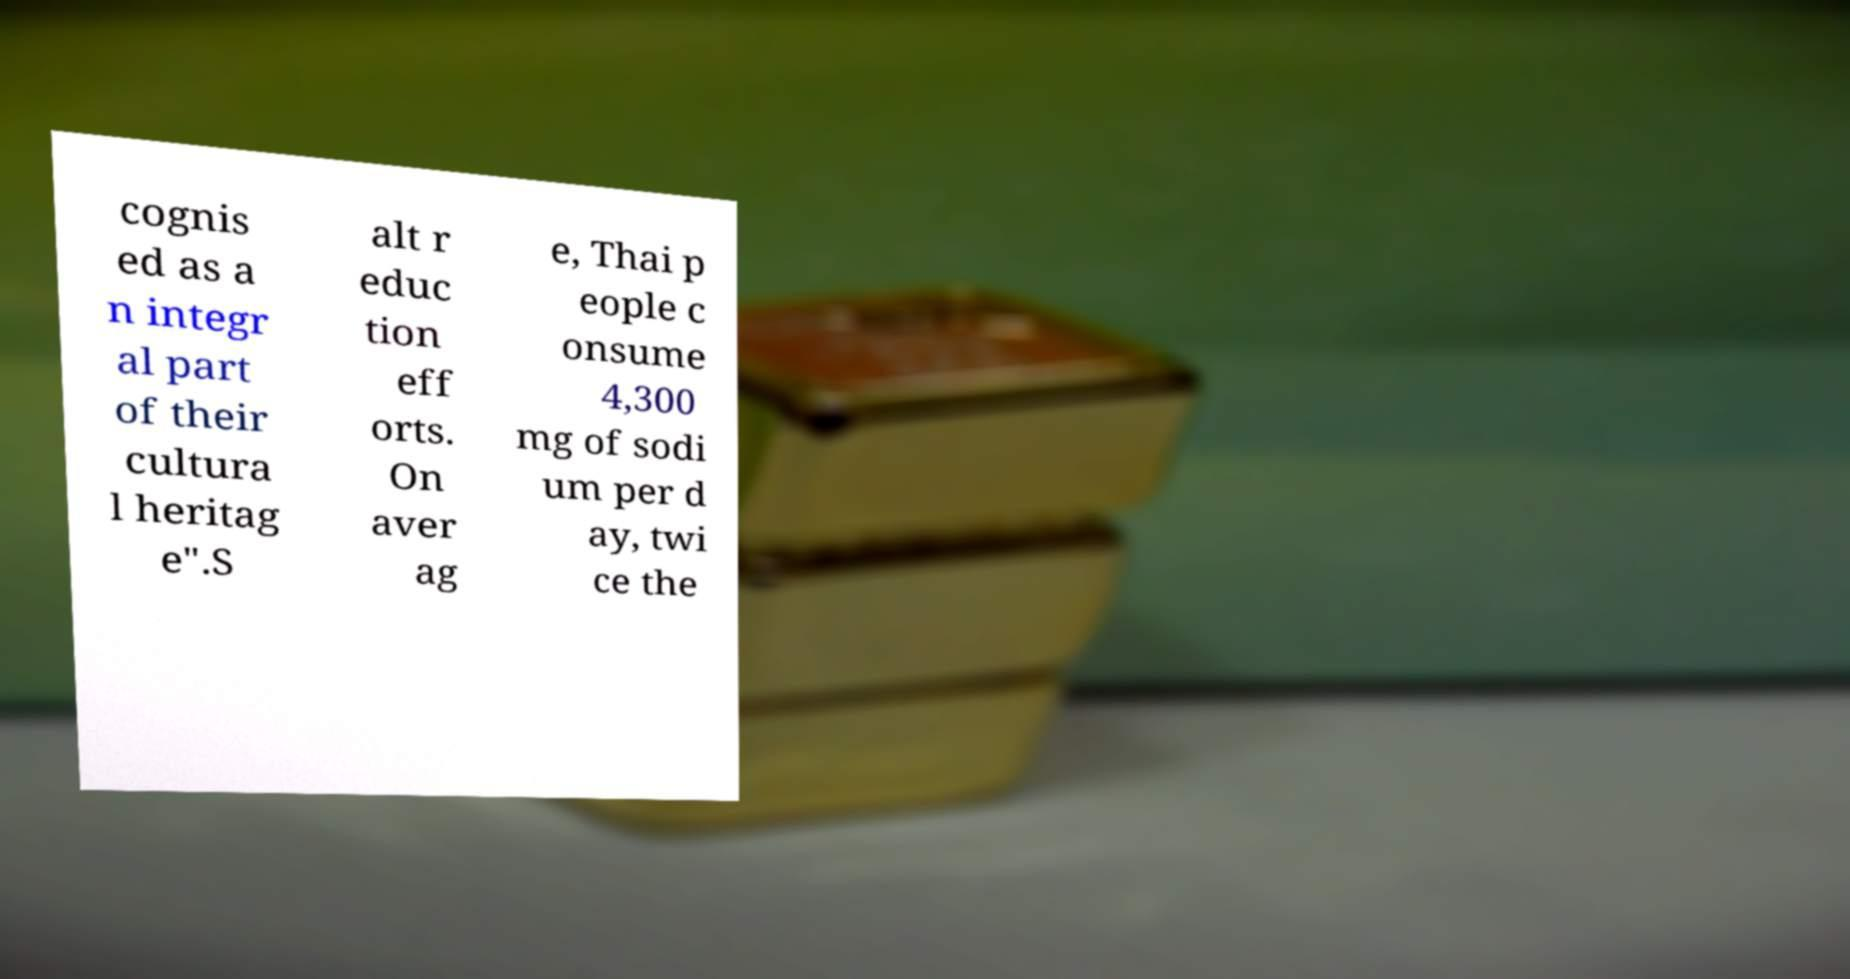Can you read and provide the text displayed in the image?This photo seems to have some interesting text. Can you extract and type it out for me? cognis ed as a n integr al part of their cultura l heritag e".S alt r educ tion eff orts. On aver ag e, Thai p eople c onsume 4,300 mg of sodi um per d ay, twi ce the 